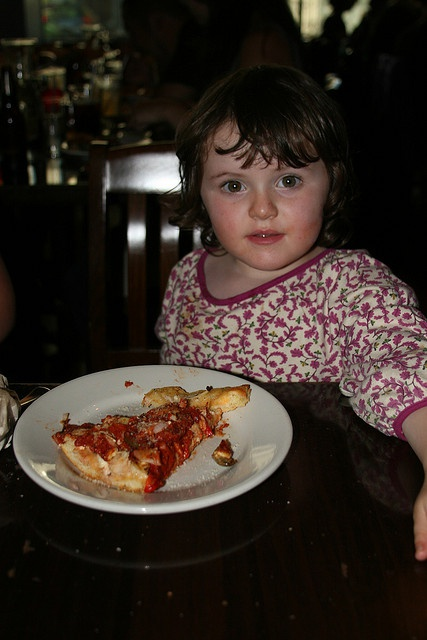Describe the objects in this image and their specific colors. I can see dining table in black, darkgray, gray, and maroon tones, people in black, gray, and darkgray tones, chair in black, lightgray, gray, and darkgray tones, pizza in black, maroon, brown, tan, and gray tones, and dining table in black, tan, darkgreen, and gray tones in this image. 